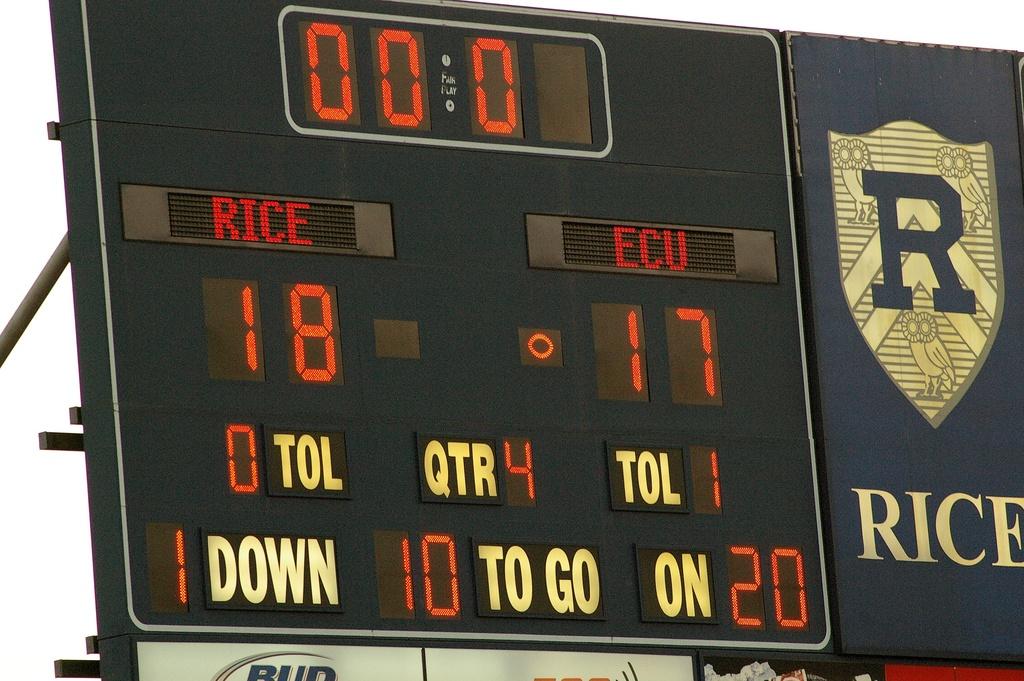What is the score?
Ensure brevity in your answer.  18-17. What team has a score of 18?
Offer a very short reply. Rice. 